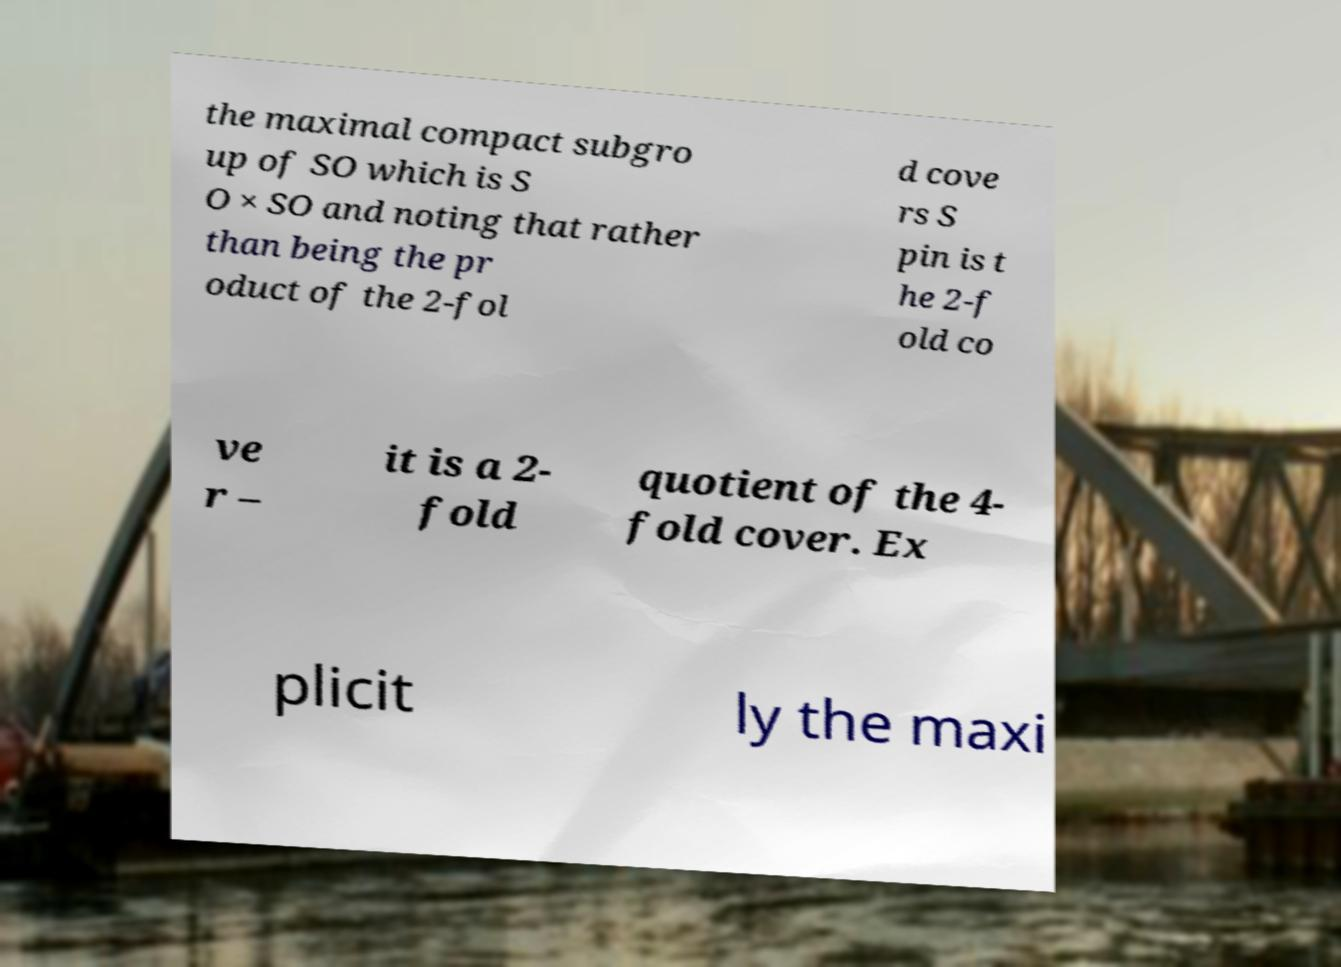For documentation purposes, I need the text within this image transcribed. Could you provide that? the maximal compact subgro up of SO which is S O × SO and noting that rather than being the pr oduct of the 2-fol d cove rs S pin is t he 2-f old co ve r – it is a 2- fold quotient of the 4- fold cover. Ex plicit ly the maxi 